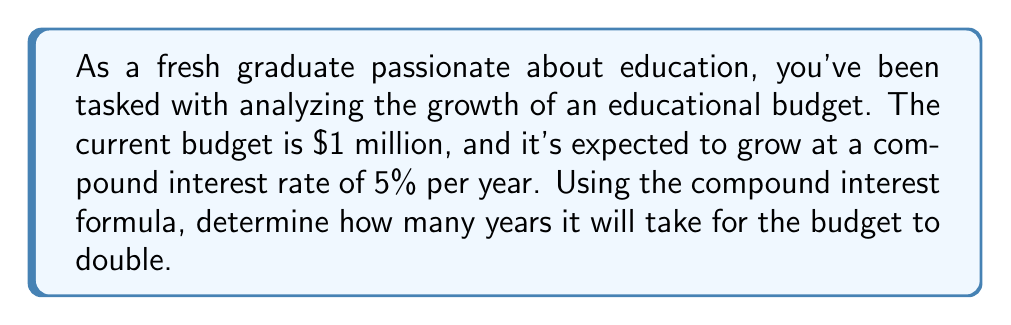Teach me how to tackle this problem. Let's approach this step-by-step using the compound interest formula and the concept of doubling time:

1) The compound interest formula is:
   $A = P(1 + r)^t$
   Where:
   $A$ = Final amount
   $P$ = Principal (initial amount)
   $r$ = Annual interest rate (in decimal form)
   $t$ = Time in years

2) We want to find when the amount doubles, so:
   $A = 2P$

3) Substituting this into our formula:
   $2P = P(1 + r)^t$

4) Divide both sides by $P$:
   $2 = (1 + r)^t$

5) Take the natural log of both sides:
   $\ln(2) = t \cdot \ln(1 + r)$

6) Solve for $t$:
   $t = \frac{\ln(2)}{\ln(1 + r)}$

7) Now, let's plug in our values:
   $r = 0.05$ (5% as a decimal)

   $t = \frac{\ln(2)}{\ln(1 + 0.05)}$

8) Calculate:
   $t = \frac{0.6931}{0.0488} \approx 14.2067$ years

9) Since we can't have a partial year in this context, we round up to the next whole year.
Answer: 15 years 